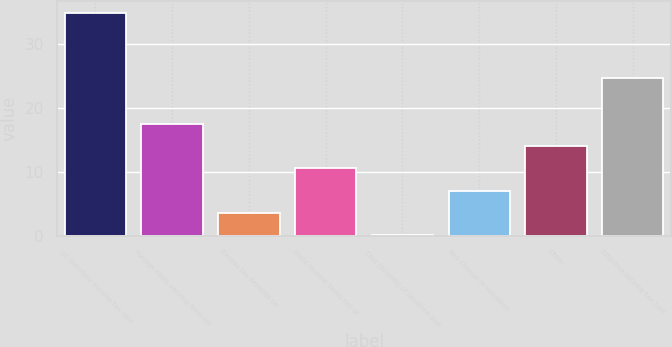<chart> <loc_0><loc_0><loc_500><loc_500><bar_chart><fcel>US statutory income tax rate<fcel>Foreign rates varying from US<fcel>Excess tax benefits on<fcel>State income taxes net of<fcel>Cost (benefit) of remitted and<fcel>Net change in valuation<fcel>Other<fcel>Effective income tax rate<nl><fcel>35<fcel>17.55<fcel>3.59<fcel>10.57<fcel>0.1<fcel>7.08<fcel>14.06<fcel>24.8<nl></chart> 